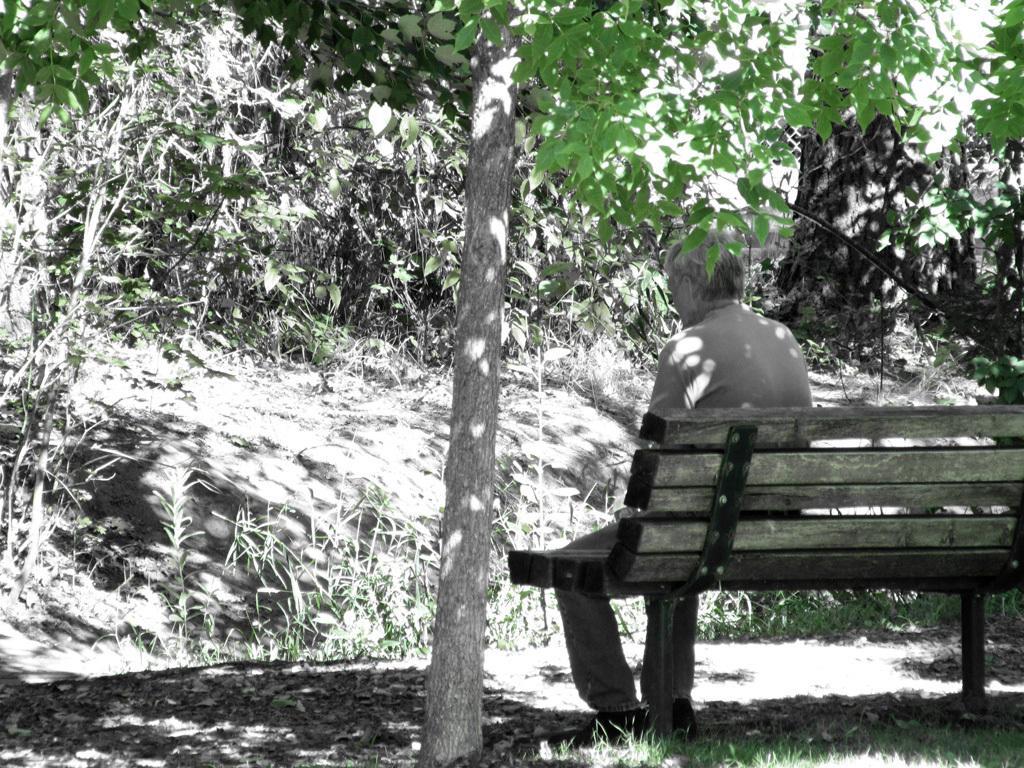Can you describe this image briefly? The image looks like it is clicked inside a garden. To the right there is a bench made up of wood. On which a man is sitting. And in the middle there are many trees. And to the front bottom there is a grass. 